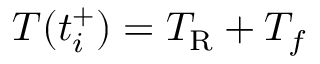Convert formula to latex. <formula><loc_0><loc_0><loc_500><loc_500>T ( t _ { i } ^ { + } ) = T _ { R } + T _ { f }</formula> 